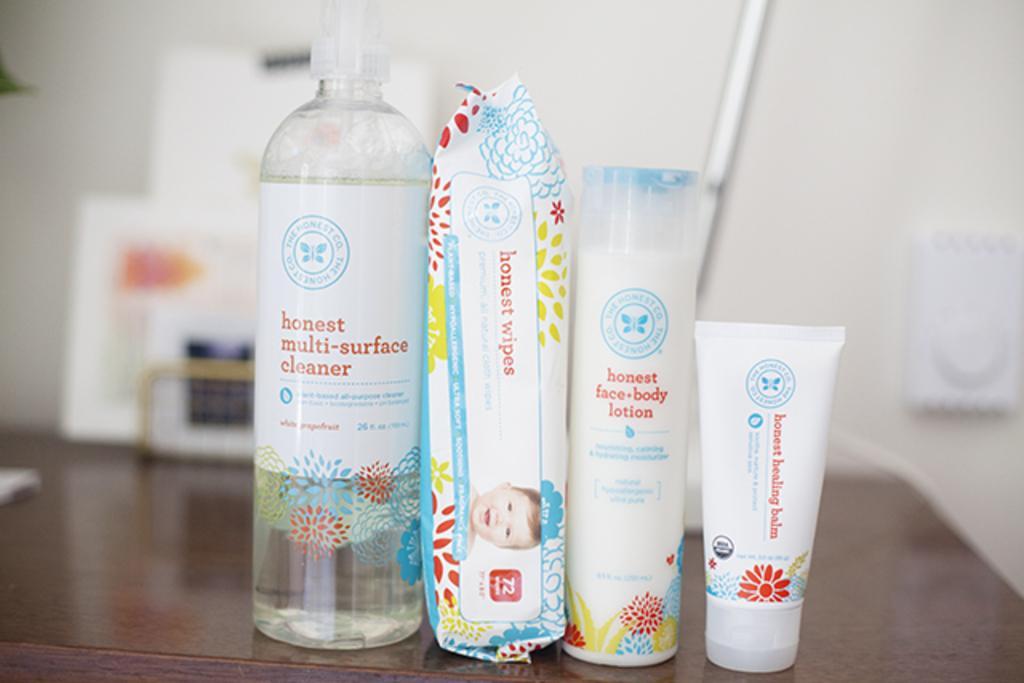In one or two sentences, can you explain what this image depicts? In this picture there is a cleaner, wipers, body lotion and a baby creams were placed on the table. In the background there is wall and some products here. 